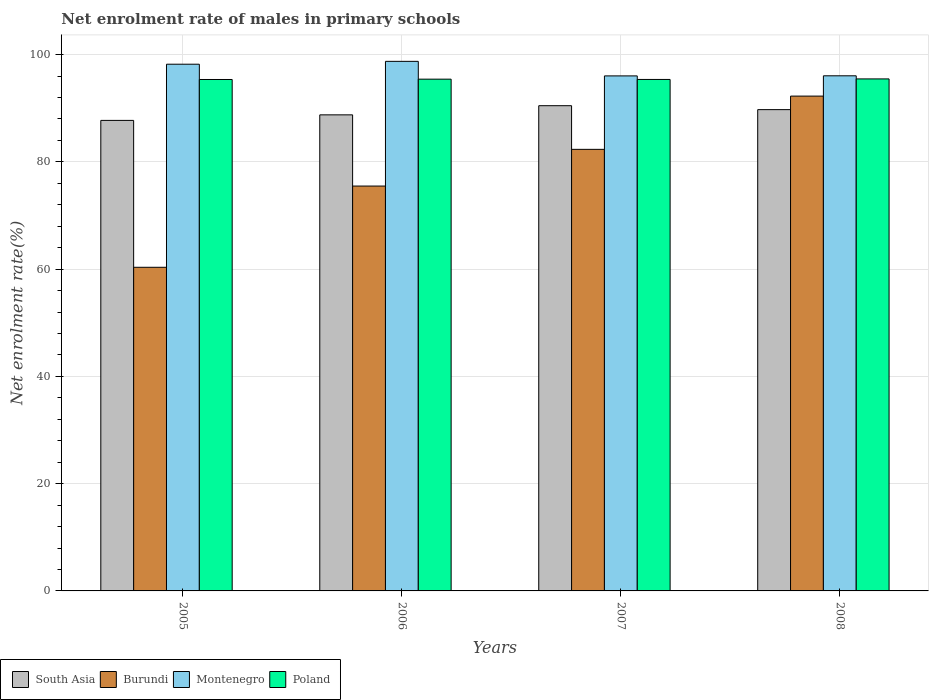Are the number of bars per tick equal to the number of legend labels?
Offer a very short reply. Yes. How many bars are there on the 4th tick from the right?
Offer a terse response. 4. What is the label of the 4th group of bars from the left?
Your answer should be very brief. 2008. In how many cases, is the number of bars for a given year not equal to the number of legend labels?
Provide a short and direct response. 0. What is the net enrolment rate of males in primary schools in Poland in 2006?
Make the answer very short. 95.41. Across all years, what is the maximum net enrolment rate of males in primary schools in South Asia?
Give a very brief answer. 90.47. Across all years, what is the minimum net enrolment rate of males in primary schools in Montenegro?
Keep it short and to the point. 96.02. In which year was the net enrolment rate of males in primary schools in Montenegro minimum?
Provide a succinct answer. 2007. What is the total net enrolment rate of males in primary schools in Montenegro in the graph?
Ensure brevity in your answer.  389. What is the difference between the net enrolment rate of males in primary schools in Poland in 2006 and that in 2008?
Your response must be concise. -0.05. What is the difference between the net enrolment rate of males in primary schools in Montenegro in 2007 and the net enrolment rate of males in primary schools in Poland in 2005?
Keep it short and to the point. 0.67. What is the average net enrolment rate of males in primary schools in Montenegro per year?
Keep it short and to the point. 97.25. In the year 2008, what is the difference between the net enrolment rate of males in primary schools in Poland and net enrolment rate of males in primary schools in Burundi?
Provide a succinct answer. 3.2. What is the ratio of the net enrolment rate of males in primary schools in Poland in 2006 to that in 2007?
Your answer should be compact. 1. Is the net enrolment rate of males in primary schools in South Asia in 2006 less than that in 2007?
Your answer should be compact. Yes. Is the difference between the net enrolment rate of males in primary schools in Poland in 2005 and 2007 greater than the difference between the net enrolment rate of males in primary schools in Burundi in 2005 and 2007?
Make the answer very short. Yes. What is the difference between the highest and the second highest net enrolment rate of males in primary schools in Burundi?
Your answer should be compact. 9.93. What is the difference between the highest and the lowest net enrolment rate of males in primary schools in Poland?
Give a very brief answer. 0.11. What does the 1st bar from the left in 2005 represents?
Your response must be concise. South Asia. What does the 4th bar from the right in 2007 represents?
Your response must be concise. South Asia. Is it the case that in every year, the sum of the net enrolment rate of males in primary schools in South Asia and net enrolment rate of males in primary schools in Burundi is greater than the net enrolment rate of males in primary schools in Poland?
Give a very brief answer. Yes. How many bars are there?
Provide a short and direct response. 16. Are all the bars in the graph horizontal?
Your answer should be very brief. No. What is the difference between two consecutive major ticks on the Y-axis?
Offer a terse response. 20. Does the graph contain grids?
Ensure brevity in your answer.  Yes. How many legend labels are there?
Your answer should be very brief. 4. How are the legend labels stacked?
Ensure brevity in your answer.  Horizontal. What is the title of the graph?
Provide a short and direct response. Net enrolment rate of males in primary schools. Does "Djibouti" appear as one of the legend labels in the graph?
Your answer should be compact. No. What is the label or title of the Y-axis?
Your response must be concise. Net enrolment rate(%). What is the Net enrolment rate(%) of South Asia in 2005?
Your answer should be very brief. 87.73. What is the Net enrolment rate(%) of Burundi in 2005?
Provide a short and direct response. 60.34. What is the Net enrolment rate(%) of Montenegro in 2005?
Offer a very short reply. 98.2. What is the Net enrolment rate(%) in Poland in 2005?
Provide a short and direct response. 95.35. What is the Net enrolment rate(%) in South Asia in 2006?
Make the answer very short. 88.76. What is the Net enrolment rate(%) in Burundi in 2006?
Provide a short and direct response. 75.48. What is the Net enrolment rate(%) in Montenegro in 2006?
Give a very brief answer. 98.73. What is the Net enrolment rate(%) in Poland in 2006?
Your answer should be very brief. 95.41. What is the Net enrolment rate(%) of South Asia in 2007?
Provide a short and direct response. 90.47. What is the Net enrolment rate(%) of Burundi in 2007?
Your answer should be very brief. 82.33. What is the Net enrolment rate(%) in Montenegro in 2007?
Provide a succinct answer. 96.02. What is the Net enrolment rate(%) of Poland in 2007?
Provide a short and direct response. 95.36. What is the Net enrolment rate(%) of South Asia in 2008?
Offer a terse response. 89.73. What is the Net enrolment rate(%) of Burundi in 2008?
Ensure brevity in your answer.  92.26. What is the Net enrolment rate(%) in Montenegro in 2008?
Give a very brief answer. 96.04. What is the Net enrolment rate(%) of Poland in 2008?
Provide a succinct answer. 95.46. Across all years, what is the maximum Net enrolment rate(%) in South Asia?
Provide a succinct answer. 90.47. Across all years, what is the maximum Net enrolment rate(%) in Burundi?
Give a very brief answer. 92.26. Across all years, what is the maximum Net enrolment rate(%) of Montenegro?
Your answer should be compact. 98.73. Across all years, what is the maximum Net enrolment rate(%) in Poland?
Make the answer very short. 95.46. Across all years, what is the minimum Net enrolment rate(%) in South Asia?
Provide a succinct answer. 87.73. Across all years, what is the minimum Net enrolment rate(%) of Burundi?
Offer a terse response. 60.34. Across all years, what is the minimum Net enrolment rate(%) in Montenegro?
Make the answer very short. 96.02. Across all years, what is the minimum Net enrolment rate(%) in Poland?
Offer a terse response. 95.35. What is the total Net enrolment rate(%) of South Asia in the graph?
Give a very brief answer. 356.69. What is the total Net enrolment rate(%) of Burundi in the graph?
Provide a short and direct response. 310.41. What is the total Net enrolment rate(%) of Montenegro in the graph?
Offer a terse response. 389. What is the total Net enrolment rate(%) in Poland in the graph?
Offer a very short reply. 381.59. What is the difference between the Net enrolment rate(%) of South Asia in 2005 and that in 2006?
Give a very brief answer. -1.04. What is the difference between the Net enrolment rate(%) of Burundi in 2005 and that in 2006?
Your answer should be compact. -15.14. What is the difference between the Net enrolment rate(%) in Montenegro in 2005 and that in 2006?
Your response must be concise. -0.53. What is the difference between the Net enrolment rate(%) of Poland in 2005 and that in 2006?
Offer a terse response. -0.06. What is the difference between the Net enrolment rate(%) in South Asia in 2005 and that in 2007?
Your answer should be very brief. -2.74. What is the difference between the Net enrolment rate(%) of Burundi in 2005 and that in 2007?
Provide a short and direct response. -21.99. What is the difference between the Net enrolment rate(%) in Montenegro in 2005 and that in 2007?
Your answer should be compact. 2.18. What is the difference between the Net enrolment rate(%) of Poland in 2005 and that in 2007?
Give a very brief answer. -0.01. What is the difference between the Net enrolment rate(%) in South Asia in 2005 and that in 2008?
Provide a short and direct response. -2.01. What is the difference between the Net enrolment rate(%) in Burundi in 2005 and that in 2008?
Your answer should be very brief. -31.92. What is the difference between the Net enrolment rate(%) of Montenegro in 2005 and that in 2008?
Keep it short and to the point. 2.16. What is the difference between the Net enrolment rate(%) of Poland in 2005 and that in 2008?
Offer a terse response. -0.11. What is the difference between the Net enrolment rate(%) of South Asia in 2006 and that in 2007?
Provide a short and direct response. -1.71. What is the difference between the Net enrolment rate(%) of Burundi in 2006 and that in 2007?
Offer a terse response. -6.84. What is the difference between the Net enrolment rate(%) in Montenegro in 2006 and that in 2007?
Provide a short and direct response. 2.71. What is the difference between the Net enrolment rate(%) of Poland in 2006 and that in 2007?
Keep it short and to the point. 0.05. What is the difference between the Net enrolment rate(%) of South Asia in 2006 and that in 2008?
Ensure brevity in your answer.  -0.97. What is the difference between the Net enrolment rate(%) of Burundi in 2006 and that in 2008?
Offer a terse response. -16.77. What is the difference between the Net enrolment rate(%) of Montenegro in 2006 and that in 2008?
Give a very brief answer. 2.7. What is the difference between the Net enrolment rate(%) of Poland in 2006 and that in 2008?
Ensure brevity in your answer.  -0.05. What is the difference between the Net enrolment rate(%) in South Asia in 2007 and that in 2008?
Offer a very short reply. 0.73. What is the difference between the Net enrolment rate(%) in Burundi in 2007 and that in 2008?
Provide a short and direct response. -9.93. What is the difference between the Net enrolment rate(%) in Montenegro in 2007 and that in 2008?
Ensure brevity in your answer.  -0.02. What is the difference between the Net enrolment rate(%) in Poland in 2007 and that in 2008?
Offer a very short reply. -0.1. What is the difference between the Net enrolment rate(%) of South Asia in 2005 and the Net enrolment rate(%) of Burundi in 2006?
Offer a terse response. 12.24. What is the difference between the Net enrolment rate(%) in South Asia in 2005 and the Net enrolment rate(%) in Montenegro in 2006?
Make the answer very short. -11.01. What is the difference between the Net enrolment rate(%) of South Asia in 2005 and the Net enrolment rate(%) of Poland in 2006?
Keep it short and to the point. -7.69. What is the difference between the Net enrolment rate(%) of Burundi in 2005 and the Net enrolment rate(%) of Montenegro in 2006?
Your response must be concise. -38.4. What is the difference between the Net enrolment rate(%) in Burundi in 2005 and the Net enrolment rate(%) in Poland in 2006?
Provide a succinct answer. -35.07. What is the difference between the Net enrolment rate(%) of Montenegro in 2005 and the Net enrolment rate(%) of Poland in 2006?
Give a very brief answer. 2.79. What is the difference between the Net enrolment rate(%) in South Asia in 2005 and the Net enrolment rate(%) in Burundi in 2007?
Offer a very short reply. 5.4. What is the difference between the Net enrolment rate(%) of South Asia in 2005 and the Net enrolment rate(%) of Montenegro in 2007?
Ensure brevity in your answer.  -8.3. What is the difference between the Net enrolment rate(%) of South Asia in 2005 and the Net enrolment rate(%) of Poland in 2007?
Ensure brevity in your answer.  -7.64. What is the difference between the Net enrolment rate(%) of Burundi in 2005 and the Net enrolment rate(%) of Montenegro in 2007?
Your answer should be compact. -35.69. What is the difference between the Net enrolment rate(%) of Burundi in 2005 and the Net enrolment rate(%) of Poland in 2007?
Keep it short and to the point. -35.02. What is the difference between the Net enrolment rate(%) in Montenegro in 2005 and the Net enrolment rate(%) in Poland in 2007?
Offer a very short reply. 2.84. What is the difference between the Net enrolment rate(%) in South Asia in 2005 and the Net enrolment rate(%) in Burundi in 2008?
Keep it short and to the point. -4.53. What is the difference between the Net enrolment rate(%) in South Asia in 2005 and the Net enrolment rate(%) in Montenegro in 2008?
Your answer should be very brief. -8.31. What is the difference between the Net enrolment rate(%) in South Asia in 2005 and the Net enrolment rate(%) in Poland in 2008?
Provide a short and direct response. -7.73. What is the difference between the Net enrolment rate(%) in Burundi in 2005 and the Net enrolment rate(%) in Montenegro in 2008?
Offer a very short reply. -35.7. What is the difference between the Net enrolment rate(%) in Burundi in 2005 and the Net enrolment rate(%) in Poland in 2008?
Offer a very short reply. -35.12. What is the difference between the Net enrolment rate(%) in Montenegro in 2005 and the Net enrolment rate(%) in Poland in 2008?
Keep it short and to the point. 2.74. What is the difference between the Net enrolment rate(%) of South Asia in 2006 and the Net enrolment rate(%) of Burundi in 2007?
Your response must be concise. 6.43. What is the difference between the Net enrolment rate(%) in South Asia in 2006 and the Net enrolment rate(%) in Montenegro in 2007?
Your response must be concise. -7.26. What is the difference between the Net enrolment rate(%) of South Asia in 2006 and the Net enrolment rate(%) of Poland in 2007?
Offer a very short reply. -6.6. What is the difference between the Net enrolment rate(%) in Burundi in 2006 and the Net enrolment rate(%) in Montenegro in 2007?
Your answer should be compact. -20.54. What is the difference between the Net enrolment rate(%) of Burundi in 2006 and the Net enrolment rate(%) of Poland in 2007?
Your response must be concise. -19.88. What is the difference between the Net enrolment rate(%) in Montenegro in 2006 and the Net enrolment rate(%) in Poland in 2007?
Give a very brief answer. 3.37. What is the difference between the Net enrolment rate(%) of South Asia in 2006 and the Net enrolment rate(%) of Burundi in 2008?
Offer a terse response. -3.5. What is the difference between the Net enrolment rate(%) of South Asia in 2006 and the Net enrolment rate(%) of Montenegro in 2008?
Your response must be concise. -7.28. What is the difference between the Net enrolment rate(%) of South Asia in 2006 and the Net enrolment rate(%) of Poland in 2008?
Ensure brevity in your answer.  -6.7. What is the difference between the Net enrolment rate(%) in Burundi in 2006 and the Net enrolment rate(%) in Montenegro in 2008?
Offer a terse response. -20.56. What is the difference between the Net enrolment rate(%) of Burundi in 2006 and the Net enrolment rate(%) of Poland in 2008?
Your answer should be compact. -19.98. What is the difference between the Net enrolment rate(%) of Montenegro in 2006 and the Net enrolment rate(%) of Poland in 2008?
Offer a terse response. 3.28. What is the difference between the Net enrolment rate(%) in South Asia in 2007 and the Net enrolment rate(%) in Burundi in 2008?
Offer a very short reply. -1.79. What is the difference between the Net enrolment rate(%) in South Asia in 2007 and the Net enrolment rate(%) in Montenegro in 2008?
Your answer should be compact. -5.57. What is the difference between the Net enrolment rate(%) in South Asia in 2007 and the Net enrolment rate(%) in Poland in 2008?
Your answer should be very brief. -4.99. What is the difference between the Net enrolment rate(%) of Burundi in 2007 and the Net enrolment rate(%) of Montenegro in 2008?
Provide a short and direct response. -13.71. What is the difference between the Net enrolment rate(%) in Burundi in 2007 and the Net enrolment rate(%) in Poland in 2008?
Provide a short and direct response. -13.13. What is the difference between the Net enrolment rate(%) of Montenegro in 2007 and the Net enrolment rate(%) of Poland in 2008?
Your response must be concise. 0.56. What is the average Net enrolment rate(%) in South Asia per year?
Ensure brevity in your answer.  89.17. What is the average Net enrolment rate(%) of Burundi per year?
Your answer should be compact. 77.6. What is the average Net enrolment rate(%) in Montenegro per year?
Give a very brief answer. 97.25. What is the average Net enrolment rate(%) of Poland per year?
Offer a terse response. 95.4. In the year 2005, what is the difference between the Net enrolment rate(%) in South Asia and Net enrolment rate(%) in Burundi?
Your answer should be very brief. 27.39. In the year 2005, what is the difference between the Net enrolment rate(%) in South Asia and Net enrolment rate(%) in Montenegro?
Offer a very short reply. -10.48. In the year 2005, what is the difference between the Net enrolment rate(%) in South Asia and Net enrolment rate(%) in Poland?
Ensure brevity in your answer.  -7.63. In the year 2005, what is the difference between the Net enrolment rate(%) in Burundi and Net enrolment rate(%) in Montenegro?
Give a very brief answer. -37.86. In the year 2005, what is the difference between the Net enrolment rate(%) of Burundi and Net enrolment rate(%) of Poland?
Make the answer very short. -35.01. In the year 2005, what is the difference between the Net enrolment rate(%) of Montenegro and Net enrolment rate(%) of Poland?
Your answer should be very brief. 2.85. In the year 2006, what is the difference between the Net enrolment rate(%) in South Asia and Net enrolment rate(%) in Burundi?
Keep it short and to the point. 13.28. In the year 2006, what is the difference between the Net enrolment rate(%) of South Asia and Net enrolment rate(%) of Montenegro?
Offer a terse response. -9.97. In the year 2006, what is the difference between the Net enrolment rate(%) of South Asia and Net enrolment rate(%) of Poland?
Your response must be concise. -6.65. In the year 2006, what is the difference between the Net enrolment rate(%) in Burundi and Net enrolment rate(%) in Montenegro?
Ensure brevity in your answer.  -23.25. In the year 2006, what is the difference between the Net enrolment rate(%) in Burundi and Net enrolment rate(%) in Poland?
Your answer should be compact. -19.93. In the year 2006, what is the difference between the Net enrolment rate(%) of Montenegro and Net enrolment rate(%) of Poland?
Make the answer very short. 3.32. In the year 2007, what is the difference between the Net enrolment rate(%) in South Asia and Net enrolment rate(%) in Burundi?
Offer a very short reply. 8.14. In the year 2007, what is the difference between the Net enrolment rate(%) of South Asia and Net enrolment rate(%) of Montenegro?
Offer a very short reply. -5.56. In the year 2007, what is the difference between the Net enrolment rate(%) of South Asia and Net enrolment rate(%) of Poland?
Your answer should be very brief. -4.89. In the year 2007, what is the difference between the Net enrolment rate(%) of Burundi and Net enrolment rate(%) of Montenegro?
Your answer should be very brief. -13.7. In the year 2007, what is the difference between the Net enrolment rate(%) in Burundi and Net enrolment rate(%) in Poland?
Ensure brevity in your answer.  -13.04. In the year 2007, what is the difference between the Net enrolment rate(%) of Montenegro and Net enrolment rate(%) of Poland?
Ensure brevity in your answer.  0.66. In the year 2008, what is the difference between the Net enrolment rate(%) in South Asia and Net enrolment rate(%) in Burundi?
Your response must be concise. -2.52. In the year 2008, what is the difference between the Net enrolment rate(%) in South Asia and Net enrolment rate(%) in Montenegro?
Offer a terse response. -6.31. In the year 2008, what is the difference between the Net enrolment rate(%) in South Asia and Net enrolment rate(%) in Poland?
Your response must be concise. -5.73. In the year 2008, what is the difference between the Net enrolment rate(%) in Burundi and Net enrolment rate(%) in Montenegro?
Ensure brevity in your answer.  -3.78. In the year 2008, what is the difference between the Net enrolment rate(%) of Burundi and Net enrolment rate(%) of Poland?
Your answer should be very brief. -3.2. In the year 2008, what is the difference between the Net enrolment rate(%) in Montenegro and Net enrolment rate(%) in Poland?
Provide a succinct answer. 0.58. What is the ratio of the Net enrolment rate(%) in South Asia in 2005 to that in 2006?
Ensure brevity in your answer.  0.99. What is the ratio of the Net enrolment rate(%) of Burundi in 2005 to that in 2006?
Your answer should be very brief. 0.8. What is the ratio of the Net enrolment rate(%) in Montenegro in 2005 to that in 2006?
Your answer should be very brief. 0.99. What is the ratio of the Net enrolment rate(%) in Poland in 2005 to that in 2006?
Your answer should be compact. 1. What is the ratio of the Net enrolment rate(%) in South Asia in 2005 to that in 2007?
Offer a very short reply. 0.97. What is the ratio of the Net enrolment rate(%) of Burundi in 2005 to that in 2007?
Provide a short and direct response. 0.73. What is the ratio of the Net enrolment rate(%) in Montenegro in 2005 to that in 2007?
Your response must be concise. 1.02. What is the ratio of the Net enrolment rate(%) in Poland in 2005 to that in 2007?
Keep it short and to the point. 1. What is the ratio of the Net enrolment rate(%) in South Asia in 2005 to that in 2008?
Give a very brief answer. 0.98. What is the ratio of the Net enrolment rate(%) in Burundi in 2005 to that in 2008?
Keep it short and to the point. 0.65. What is the ratio of the Net enrolment rate(%) of Montenegro in 2005 to that in 2008?
Your response must be concise. 1.02. What is the ratio of the Net enrolment rate(%) in South Asia in 2006 to that in 2007?
Provide a succinct answer. 0.98. What is the ratio of the Net enrolment rate(%) of Burundi in 2006 to that in 2007?
Your response must be concise. 0.92. What is the ratio of the Net enrolment rate(%) of Montenegro in 2006 to that in 2007?
Provide a short and direct response. 1.03. What is the ratio of the Net enrolment rate(%) in South Asia in 2006 to that in 2008?
Your answer should be very brief. 0.99. What is the ratio of the Net enrolment rate(%) of Burundi in 2006 to that in 2008?
Keep it short and to the point. 0.82. What is the ratio of the Net enrolment rate(%) in Montenegro in 2006 to that in 2008?
Your response must be concise. 1.03. What is the ratio of the Net enrolment rate(%) in South Asia in 2007 to that in 2008?
Your answer should be very brief. 1.01. What is the ratio of the Net enrolment rate(%) in Burundi in 2007 to that in 2008?
Your answer should be compact. 0.89. What is the ratio of the Net enrolment rate(%) in Poland in 2007 to that in 2008?
Your answer should be compact. 1. What is the difference between the highest and the second highest Net enrolment rate(%) of South Asia?
Provide a short and direct response. 0.73. What is the difference between the highest and the second highest Net enrolment rate(%) in Burundi?
Your answer should be very brief. 9.93. What is the difference between the highest and the second highest Net enrolment rate(%) in Montenegro?
Ensure brevity in your answer.  0.53. What is the difference between the highest and the second highest Net enrolment rate(%) in Poland?
Ensure brevity in your answer.  0.05. What is the difference between the highest and the lowest Net enrolment rate(%) in South Asia?
Provide a short and direct response. 2.74. What is the difference between the highest and the lowest Net enrolment rate(%) in Burundi?
Your answer should be very brief. 31.92. What is the difference between the highest and the lowest Net enrolment rate(%) of Montenegro?
Offer a very short reply. 2.71. What is the difference between the highest and the lowest Net enrolment rate(%) in Poland?
Give a very brief answer. 0.11. 